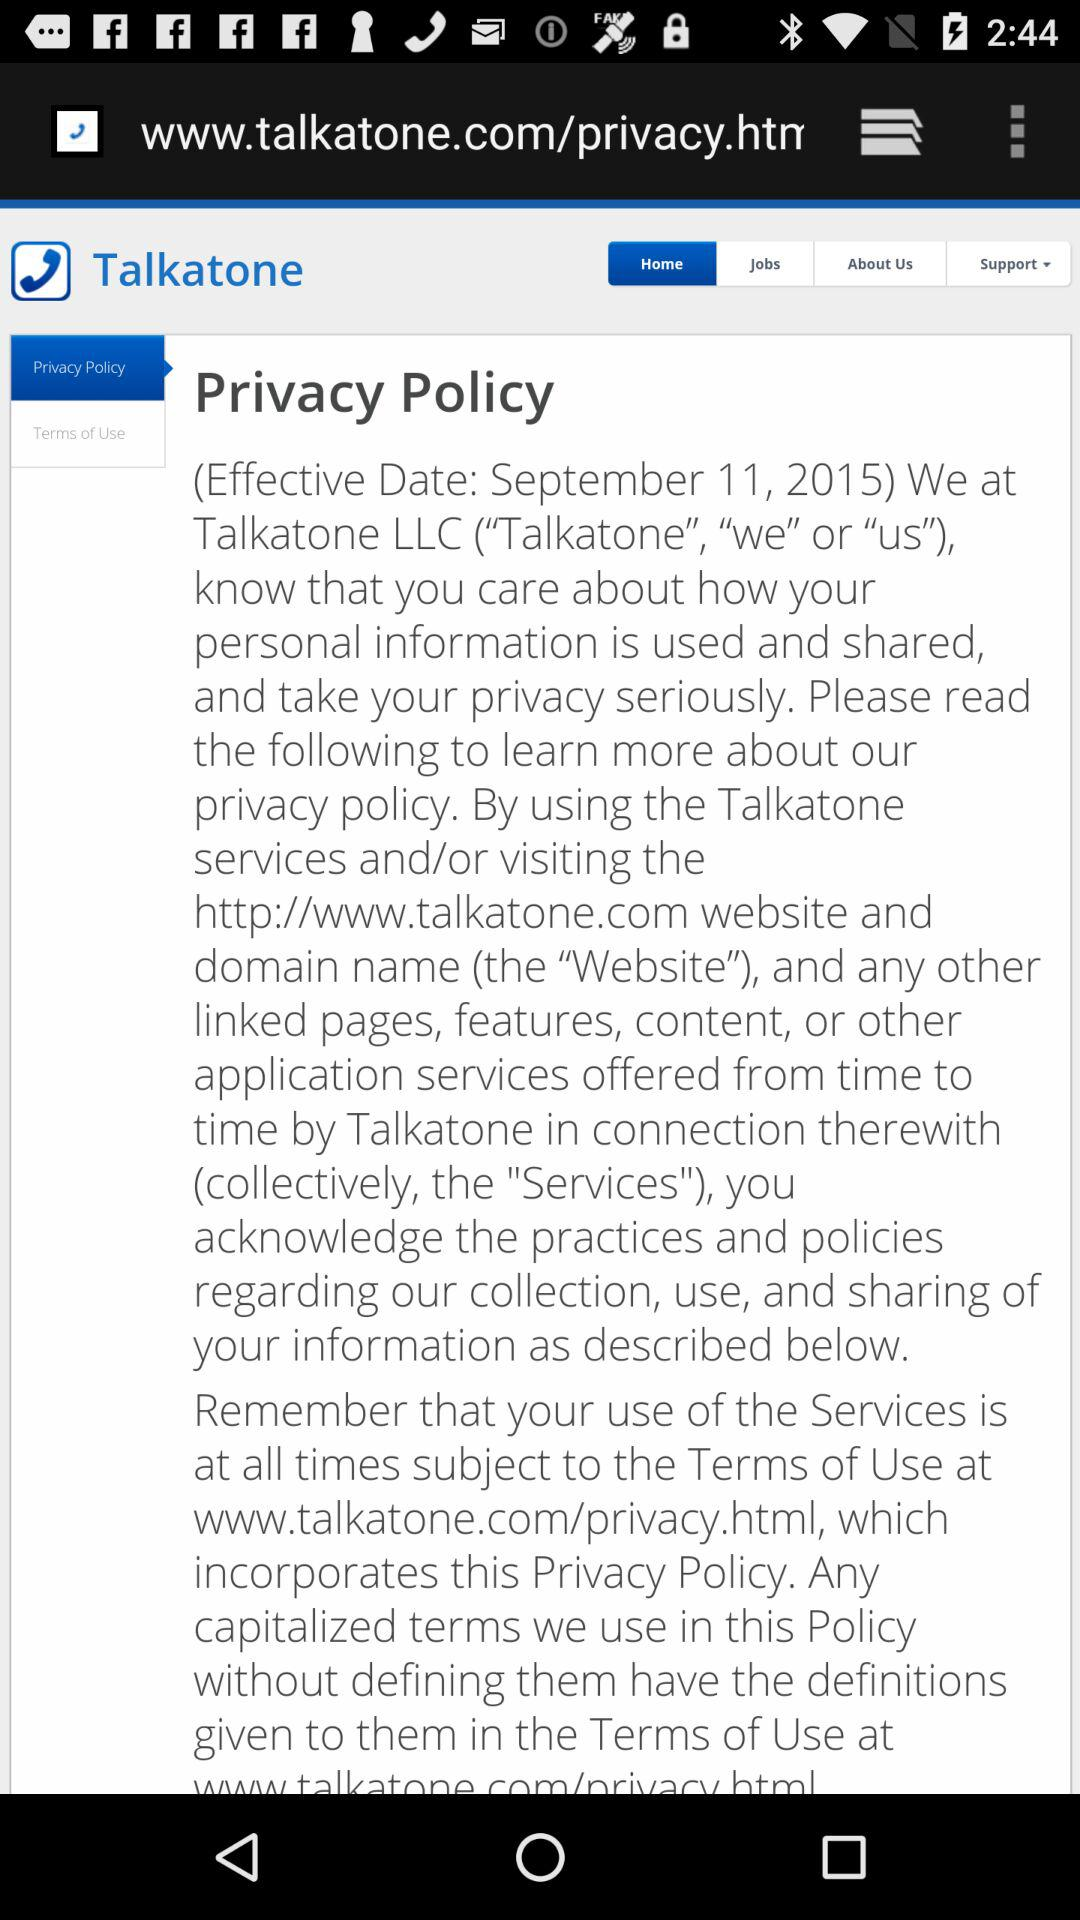Which options are available for contacting support?
When the provided information is insufficient, respond with <no answer>. <no answer> 